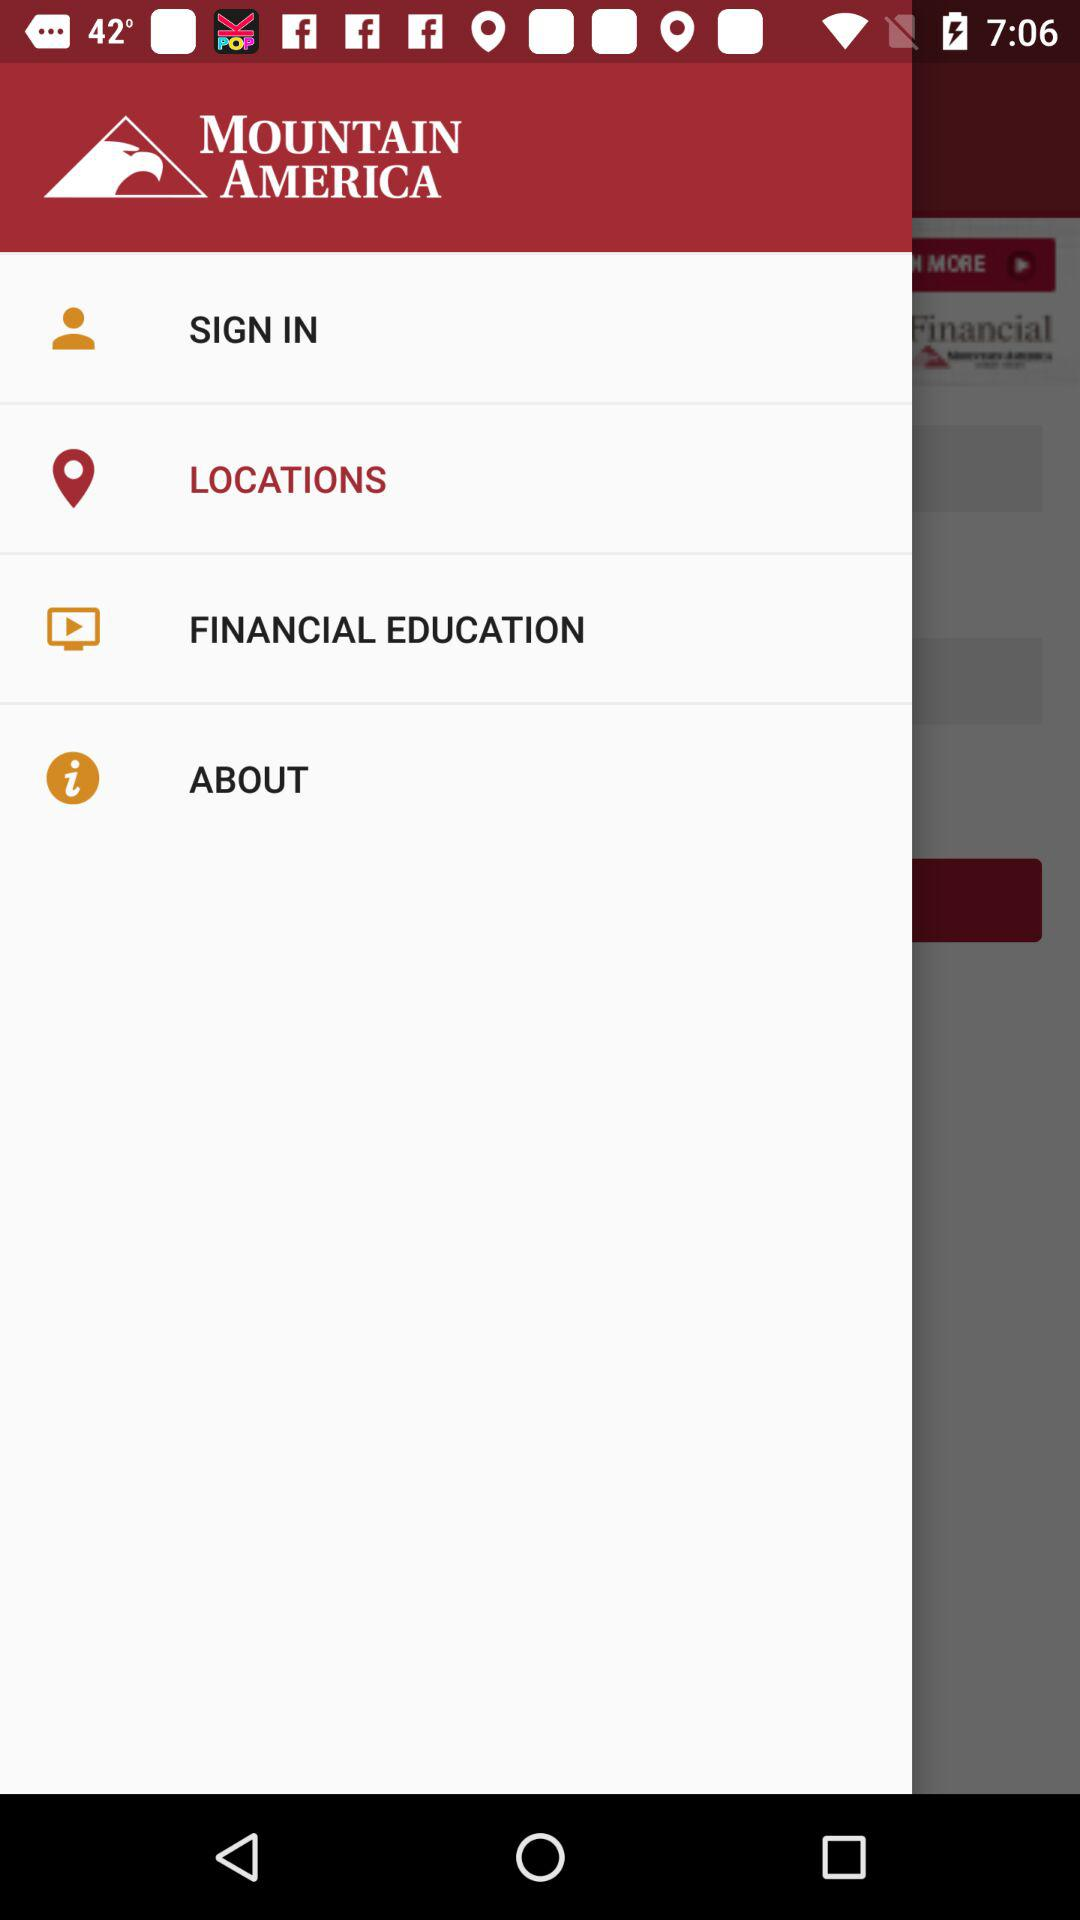Who is signing in?
When the provided information is insufficient, respond with <no answer>. <no answer> 